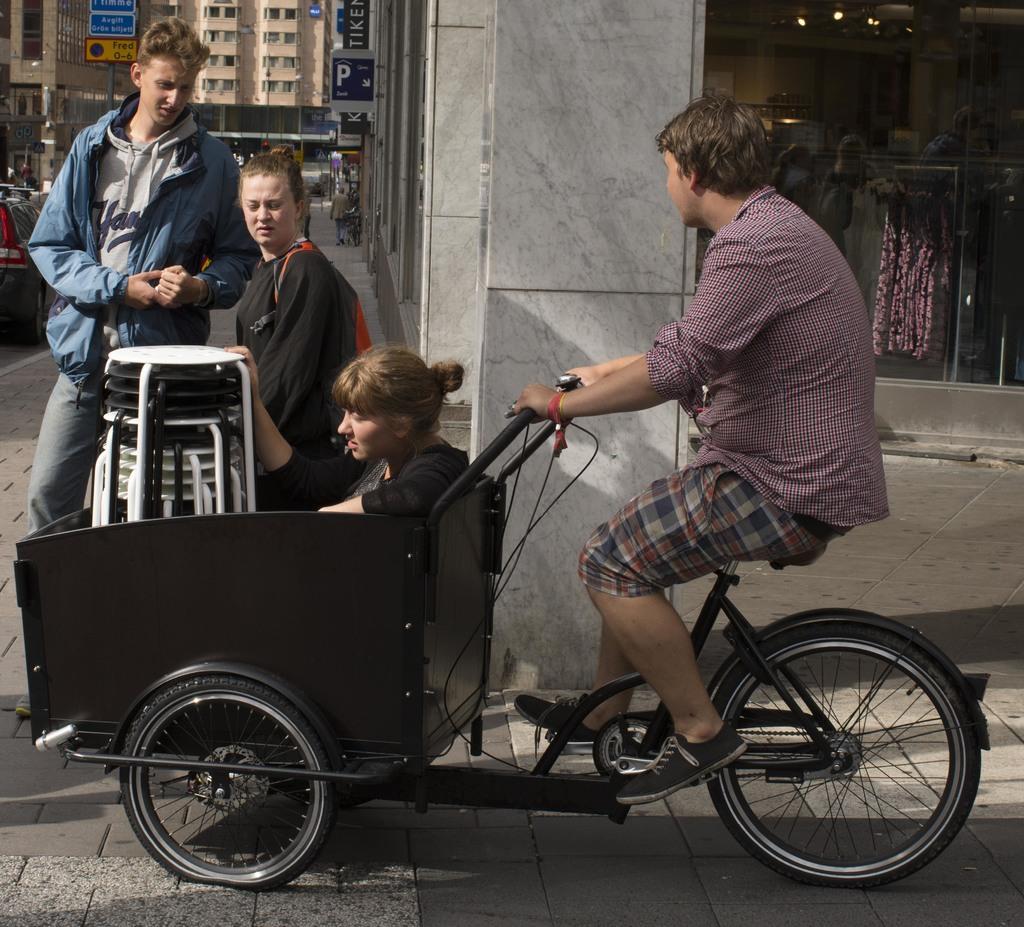Please provide a concise description of this image. In this image I see 2 men and 2 women in which this man is riding this cycle and this woman is sitting in this trolley and I see few things over here and these both are standing and I see the path. In the background I see number of building and boards on which something is written and I see a car over here. 